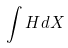Convert formula to latex. <formula><loc_0><loc_0><loc_500><loc_500>\int H d X</formula> 